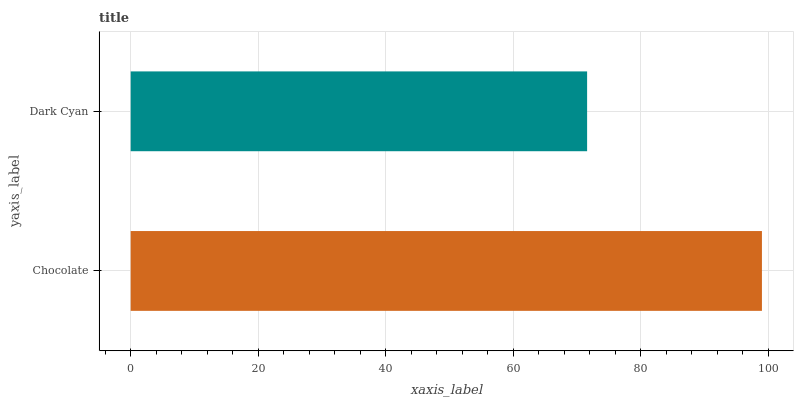Is Dark Cyan the minimum?
Answer yes or no. Yes. Is Chocolate the maximum?
Answer yes or no. Yes. Is Dark Cyan the maximum?
Answer yes or no. No. Is Chocolate greater than Dark Cyan?
Answer yes or no. Yes. Is Dark Cyan less than Chocolate?
Answer yes or no. Yes. Is Dark Cyan greater than Chocolate?
Answer yes or no. No. Is Chocolate less than Dark Cyan?
Answer yes or no. No. Is Chocolate the high median?
Answer yes or no. Yes. Is Dark Cyan the low median?
Answer yes or no. Yes. Is Dark Cyan the high median?
Answer yes or no. No. Is Chocolate the low median?
Answer yes or no. No. 